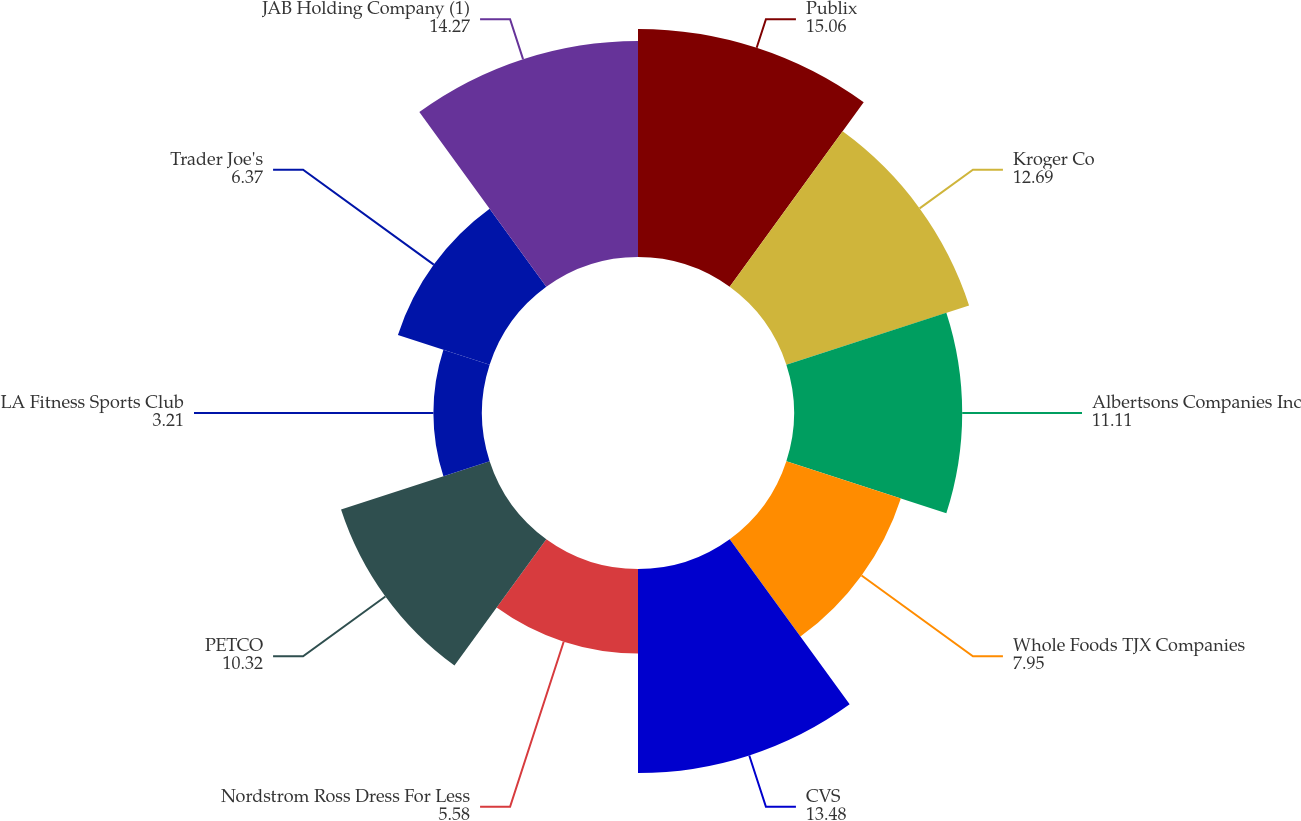Convert chart. <chart><loc_0><loc_0><loc_500><loc_500><pie_chart><fcel>Publix<fcel>Kroger Co<fcel>Albertsons Companies Inc<fcel>Whole Foods TJX Companies<fcel>CVS<fcel>Nordstrom Ross Dress For Less<fcel>PETCO<fcel>LA Fitness Sports Club<fcel>Trader Joe's<fcel>JAB Holding Company (1)<nl><fcel>15.06%<fcel>12.69%<fcel>11.11%<fcel>7.95%<fcel>13.48%<fcel>5.58%<fcel>10.32%<fcel>3.21%<fcel>6.37%<fcel>14.27%<nl></chart> 